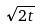Convert formula to latex. <formula><loc_0><loc_0><loc_500><loc_500>\sqrt { 2 t }</formula> 